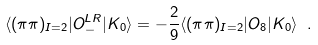Convert formula to latex. <formula><loc_0><loc_0><loc_500><loc_500>\langle ( \pi \pi ) _ { I = 2 } | O _ { - } ^ { L R } | K _ { 0 } \rangle = - \frac { 2 } { 9 } \langle ( \pi \pi ) _ { I = 2 } | O _ { 8 } | K _ { 0 } \rangle \ .</formula> 